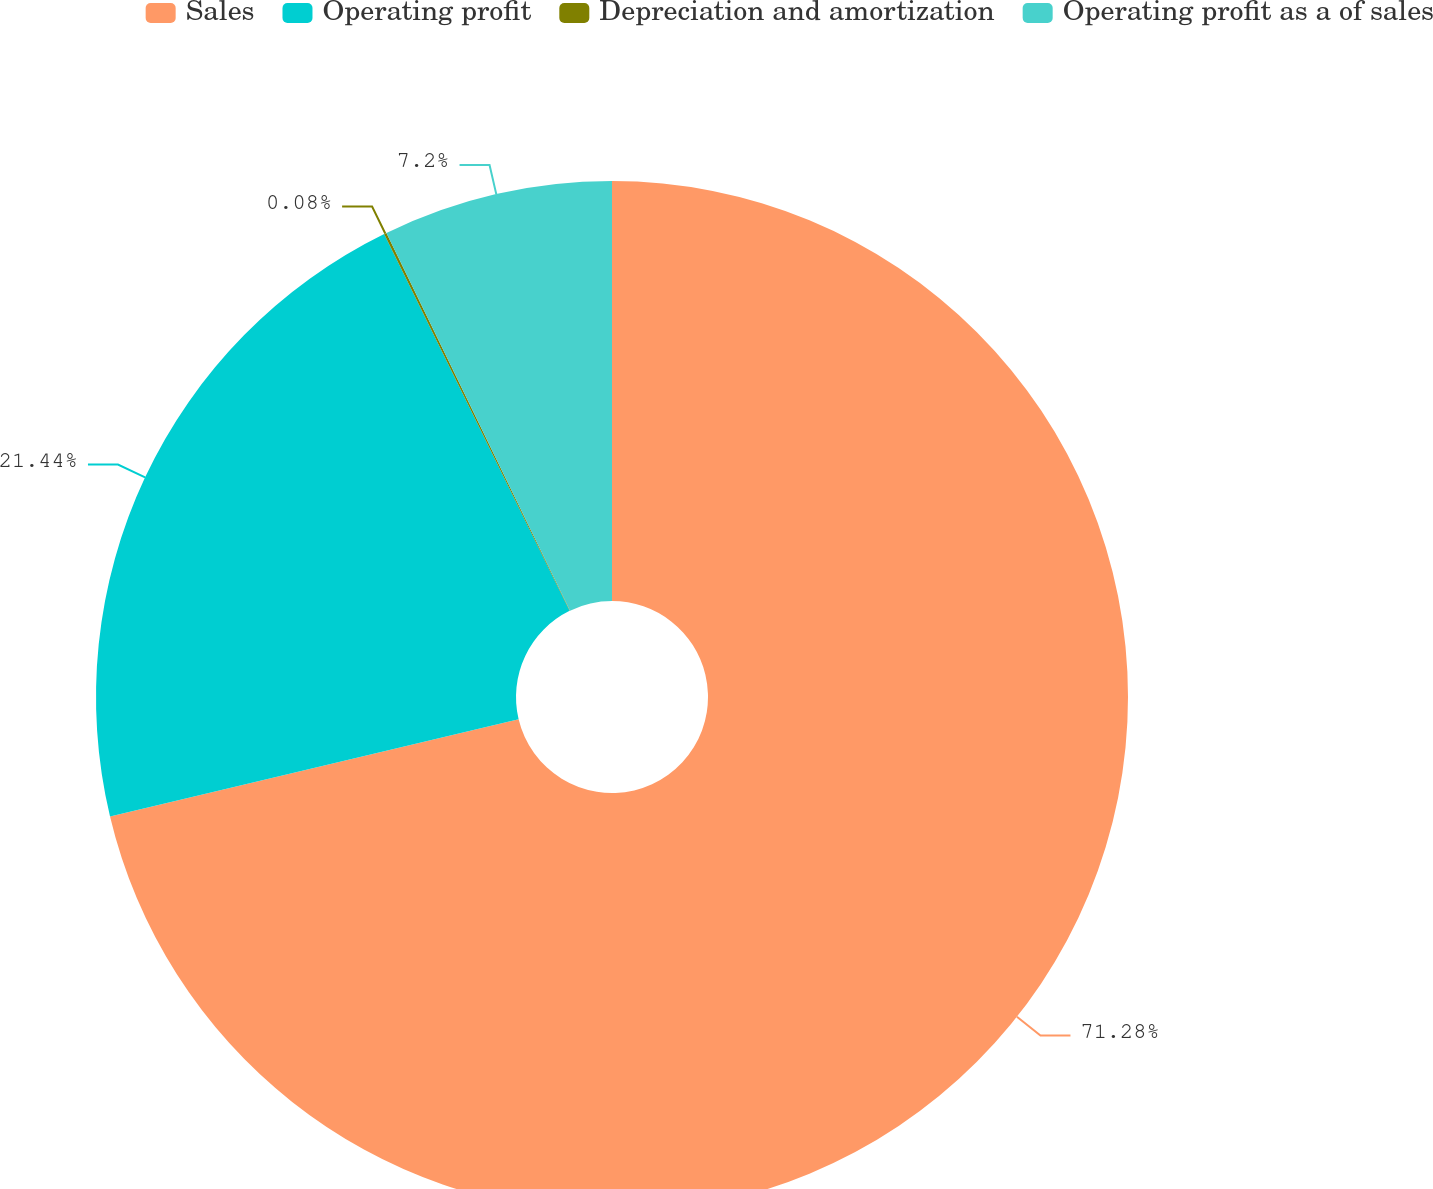Convert chart. <chart><loc_0><loc_0><loc_500><loc_500><pie_chart><fcel>Sales<fcel>Operating profit<fcel>Depreciation and amortization<fcel>Operating profit as a of sales<nl><fcel>71.28%<fcel>21.44%<fcel>0.08%<fcel>7.2%<nl></chart> 